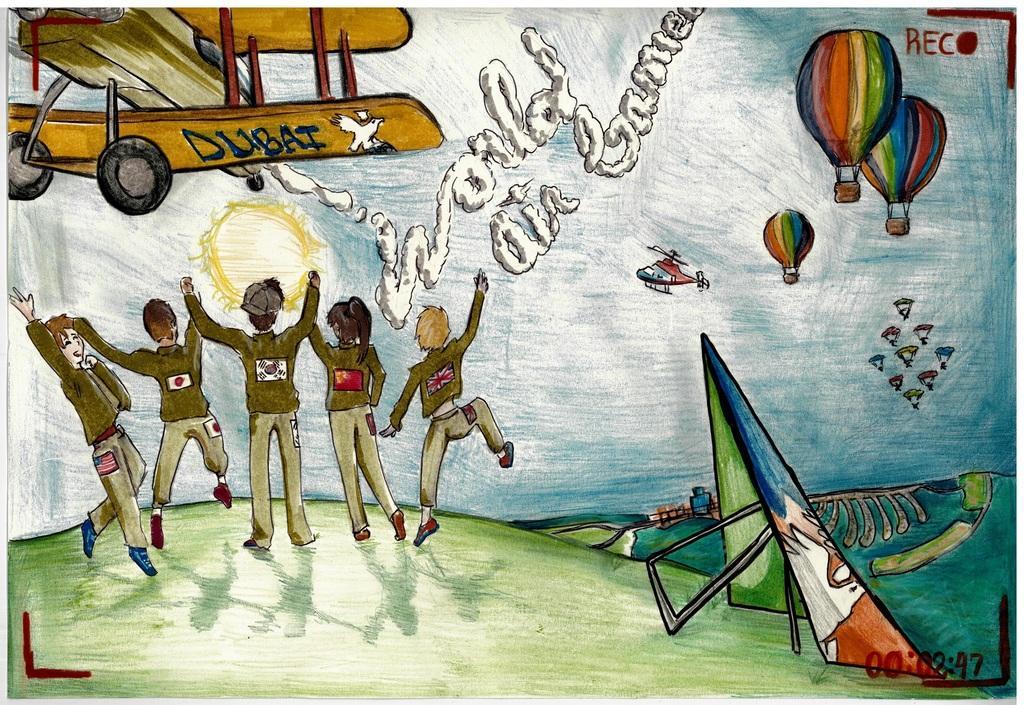In one or two sentences, can you explain what this image depicts? In this image I can see few people standing and wearing different color dresses. I can see two aircraft's, sun and few colorful parachutes flying and few colorful objects on the ground. At the top I can see something is written in red color. 